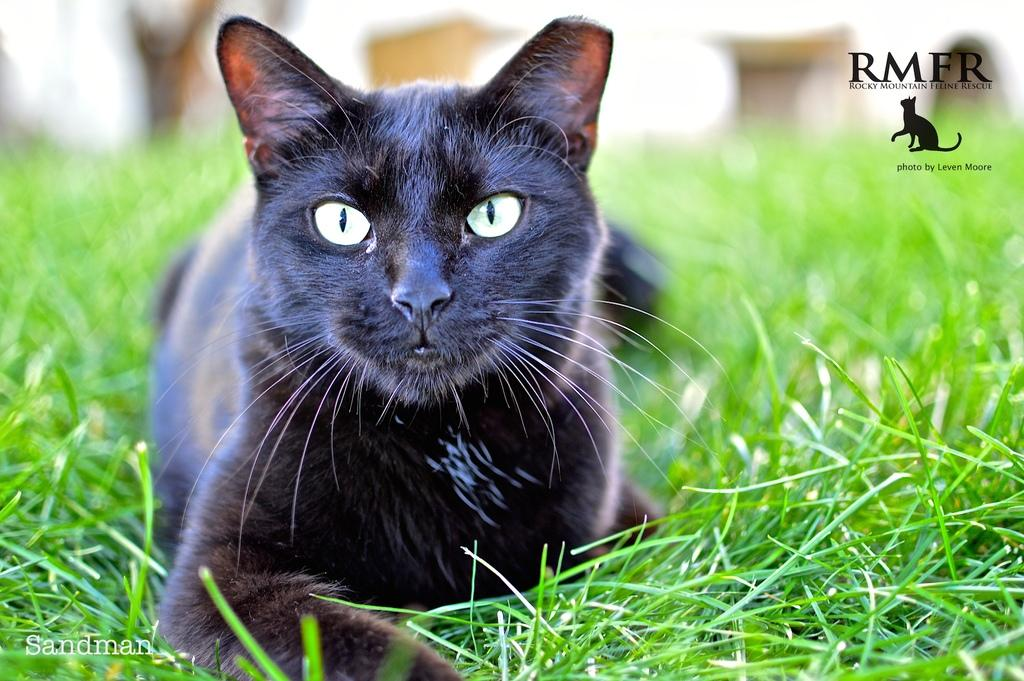What type of animal is in the image? There is a black cat in the image. What is the cat doing in the image? The cat is lying on the grass. Can you describe the background of the image? The background of the image is blurred. Are there any visible marks on the image? Yes, there are watermarks on the image. What type of pencil is the cat holding in the image? There is no pencil present in the image, and the cat is not holding anything. 